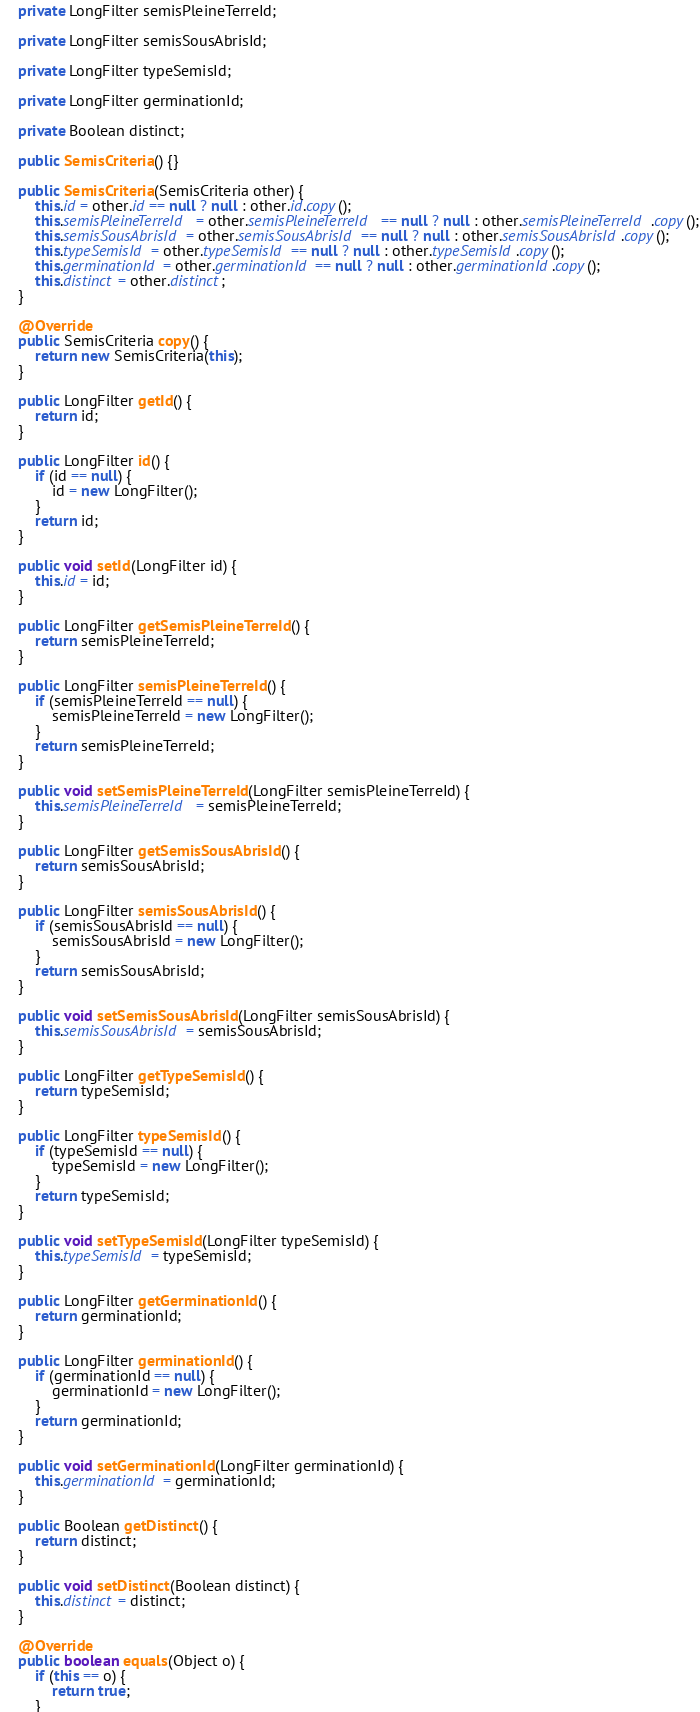<code> <loc_0><loc_0><loc_500><loc_500><_Java_>    private LongFilter semisPleineTerreId;

    private LongFilter semisSousAbrisId;

    private LongFilter typeSemisId;

    private LongFilter germinationId;

    private Boolean distinct;

    public SemisCriteria() {}

    public SemisCriteria(SemisCriteria other) {
        this.id = other.id == null ? null : other.id.copy();
        this.semisPleineTerreId = other.semisPleineTerreId == null ? null : other.semisPleineTerreId.copy();
        this.semisSousAbrisId = other.semisSousAbrisId == null ? null : other.semisSousAbrisId.copy();
        this.typeSemisId = other.typeSemisId == null ? null : other.typeSemisId.copy();
        this.germinationId = other.germinationId == null ? null : other.germinationId.copy();
        this.distinct = other.distinct;
    }

    @Override
    public SemisCriteria copy() {
        return new SemisCriteria(this);
    }

    public LongFilter getId() {
        return id;
    }

    public LongFilter id() {
        if (id == null) {
            id = new LongFilter();
        }
        return id;
    }

    public void setId(LongFilter id) {
        this.id = id;
    }

    public LongFilter getSemisPleineTerreId() {
        return semisPleineTerreId;
    }

    public LongFilter semisPleineTerreId() {
        if (semisPleineTerreId == null) {
            semisPleineTerreId = new LongFilter();
        }
        return semisPleineTerreId;
    }

    public void setSemisPleineTerreId(LongFilter semisPleineTerreId) {
        this.semisPleineTerreId = semisPleineTerreId;
    }

    public LongFilter getSemisSousAbrisId() {
        return semisSousAbrisId;
    }

    public LongFilter semisSousAbrisId() {
        if (semisSousAbrisId == null) {
            semisSousAbrisId = new LongFilter();
        }
        return semisSousAbrisId;
    }

    public void setSemisSousAbrisId(LongFilter semisSousAbrisId) {
        this.semisSousAbrisId = semisSousAbrisId;
    }

    public LongFilter getTypeSemisId() {
        return typeSemisId;
    }

    public LongFilter typeSemisId() {
        if (typeSemisId == null) {
            typeSemisId = new LongFilter();
        }
        return typeSemisId;
    }

    public void setTypeSemisId(LongFilter typeSemisId) {
        this.typeSemisId = typeSemisId;
    }

    public LongFilter getGerminationId() {
        return germinationId;
    }

    public LongFilter germinationId() {
        if (germinationId == null) {
            germinationId = new LongFilter();
        }
        return germinationId;
    }

    public void setGerminationId(LongFilter germinationId) {
        this.germinationId = germinationId;
    }

    public Boolean getDistinct() {
        return distinct;
    }

    public void setDistinct(Boolean distinct) {
        this.distinct = distinct;
    }

    @Override
    public boolean equals(Object o) {
        if (this == o) {
            return true;
        }</code> 